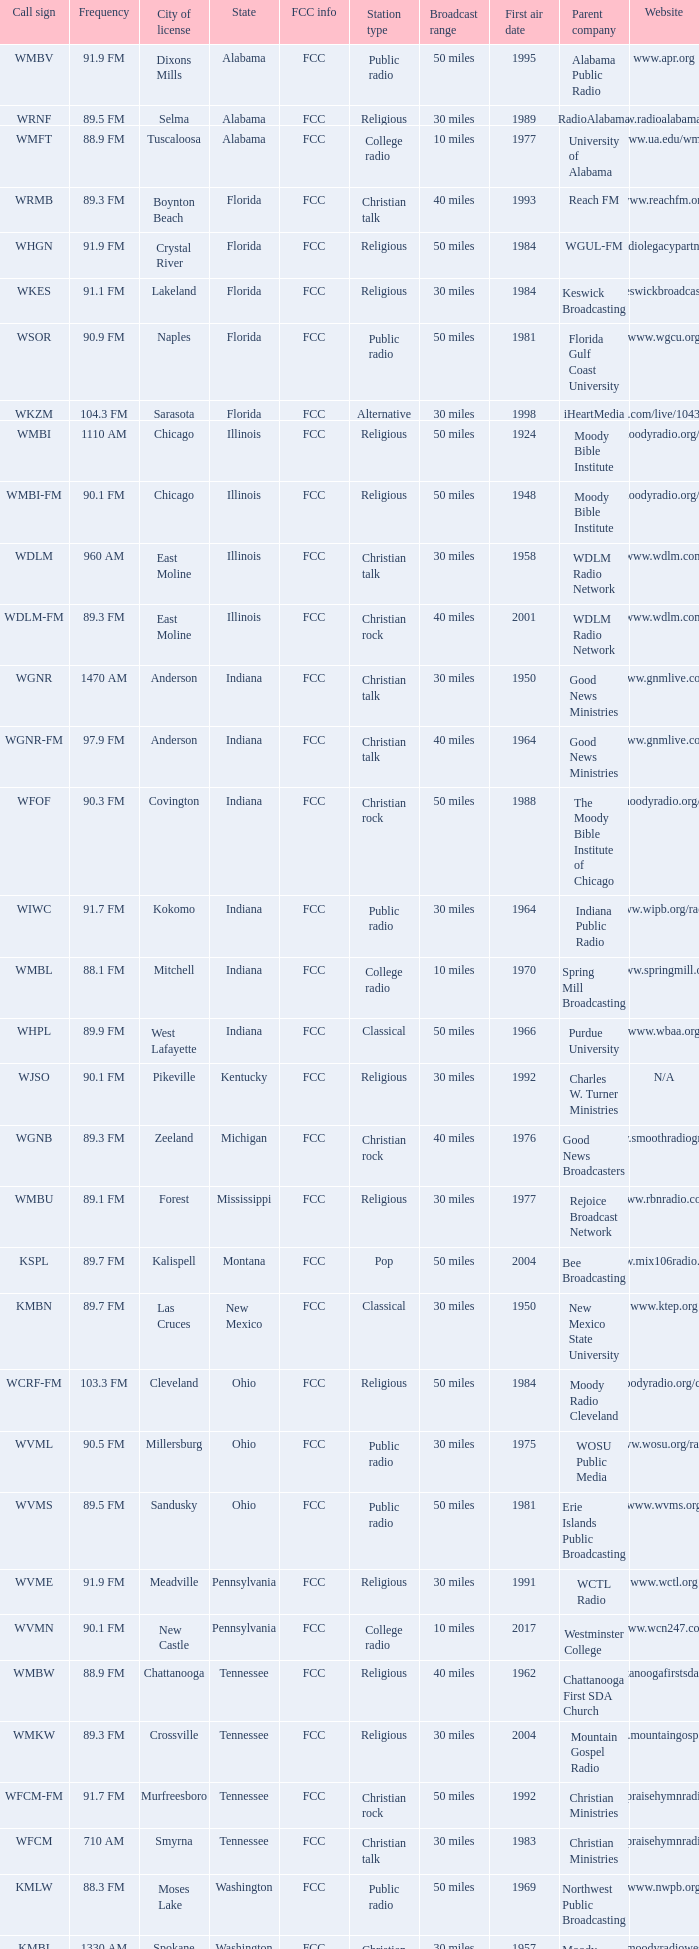What are the fcc-related specifics for the radio station in west lafayette, indiana? FCC. 